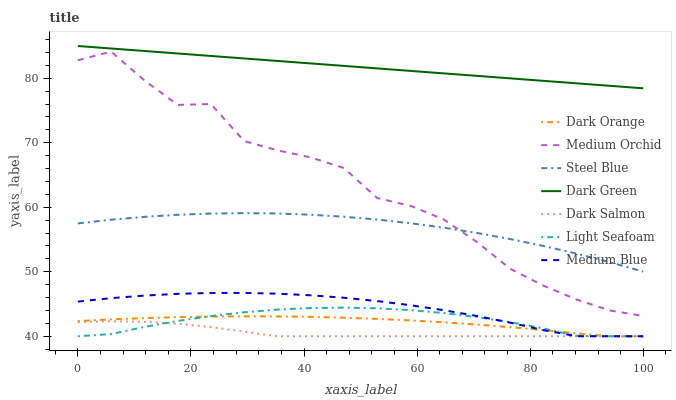Does Dark Salmon have the minimum area under the curve?
Answer yes or no. Yes. Does Dark Green have the maximum area under the curve?
Answer yes or no. Yes. Does Medium Orchid have the minimum area under the curve?
Answer yes or no. No. Does Medium Orchid have the maximum area under the curve?
Answer yes or no. No. Is Dark Green the smoothest?
Answer yes or no. Yes. Is Medium Orchid the roughest?
Answer yes or no. Yes. Is Medium Blue the smoothest?
Answer yes or no. No. Is Medium Blue the roughest?
Answer yes or no. No. Does Medium Orchid have the lowest value?
Answer yes or no. No. Does Medium Orchid have the highest value?
Answer yes or no. No. Is Light Seafoam less than Steel Blue?
Answer yes or no. Yes. Is Steel Blue greater than Light Seafoam?
Answer yes or no. Yes. Does Light Seafoam intersect Steel Blue?
Answer yes or no. No. 